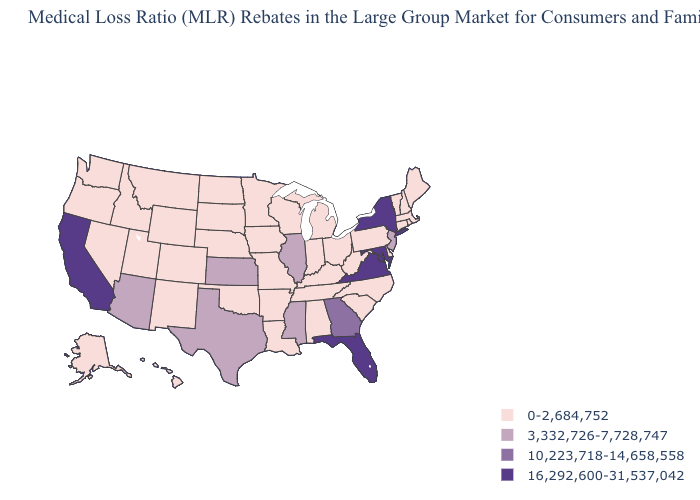What is the highest value in states that border Alabama?
Write a very short answer. 16,292,600-31,537,042. How many symbols are there in the legend?
Answer briefly. 4. What is the value of Pennsylvania?
Give a very brief answer. 0-2,684,752. What is the lowest value in the West?
Write a very short answer. 0-2,684,752. Name the states that have a value in the range 0-2,684,752?
Give a very brief answer. Alabama, Alaska, Arkansas, Colorado, Connecticut, Delaware, Hawaii, Idaho, Indiana, Iowa, Kentucky, Louisiana, Maine, Massachusetts, Michigan, Minnesota, Missouri, Montana, Nebraska, Nevada, New Hampshire, New Mexico, North Carolina, North Dakota, Ohio, Oklahoma, Oregon, Pennsylvania, Rhode Island, South Carolina, South Dakota, Tennessee, Utah, Vermont, Washington, West Virginia, Wisconsin, Wyoming. What is the value of Alaska?
Short answer required. 0-2,684,752. Among the states that border Florida , which have the highest value?
Quick response, please. Georgia. Does New York have the lowest value in the Northeast?
Concise answer only. No. Among the states that border Wisconsin , which have the highest value?
Answer briefly. Illinois. Does the map have missing data?
Short answer required. No. What is the value of Missouri?
Write a very short answer. 0-2,684,752. Which states have the lowest value in the USA?
Quick response, please. Alabama, Alaska, Arkansas, Colorado, Connecticut, Delaware, Hawaii, Idaho, Indiana, Iowa, Kentucky, Louisiana, Maine, Massachusetts, Michigan, Minnesota, Missouri, Montana, Nebraska, Nevada, New Hampshire, New Mexico, North Carolina, North Dakota, Ohio, Oklahoma, Oregon, Pennsylvania, Rhode Island, South Carolina, South Dakota, Tennessee, Utah, Vermont, Washington, West Virginia, Wisconsin, Wyoming. Does California have the lowest value in the West?
Write a very short answer. No. Name the states that have a value in the range 10,223,718-14,658,558?
Concise answer only. Georgia. Does Florida have the lowest value in the USA?
Be succinct. No. 